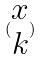Convert formula to latex. <formula><loc_0><loc_0><loc_500><loc_500>( \begin{matrix} x \\ k \end{matrix} )</formula> 